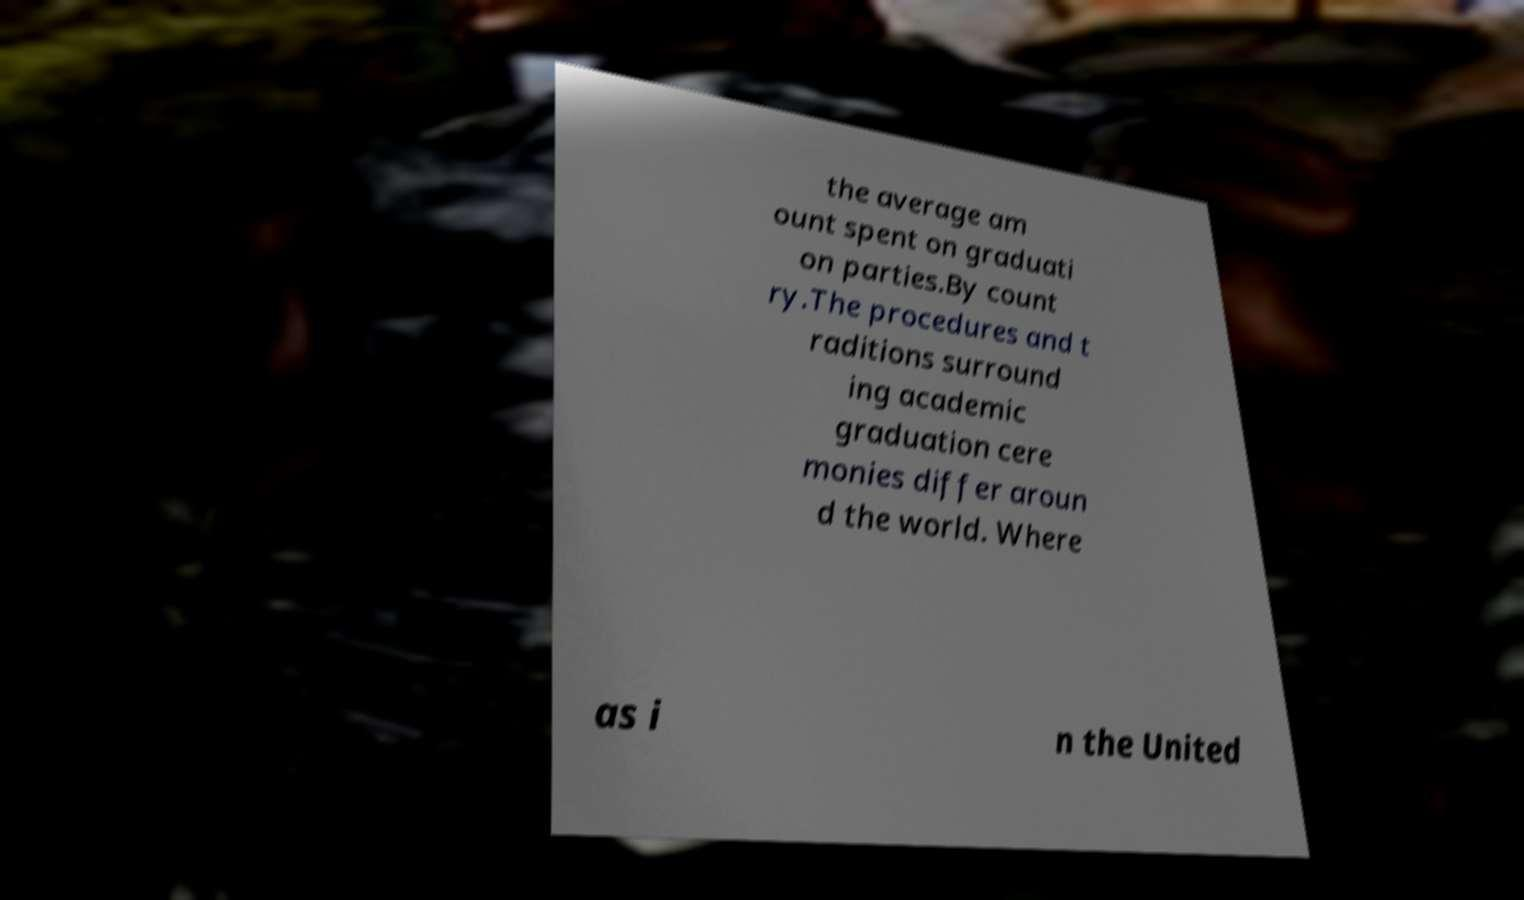Please identify and transcribe the text found in this image. the average am ount spent on graduati on parties.By count ry.The procedures and t raditions surround ing academic graduation cere monies differ aroun d the world. Where as i n the United 